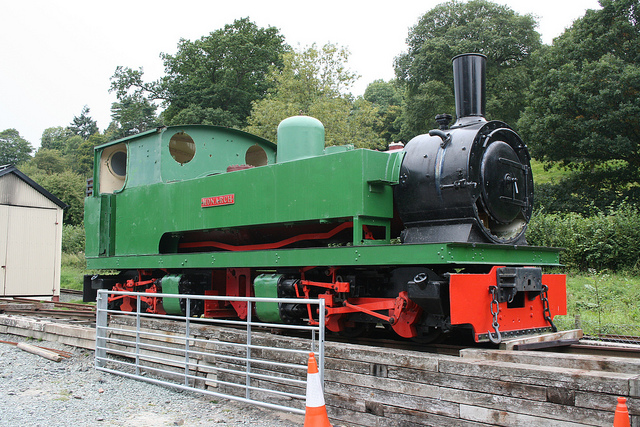Read and extract the text from this image. MONARCH 